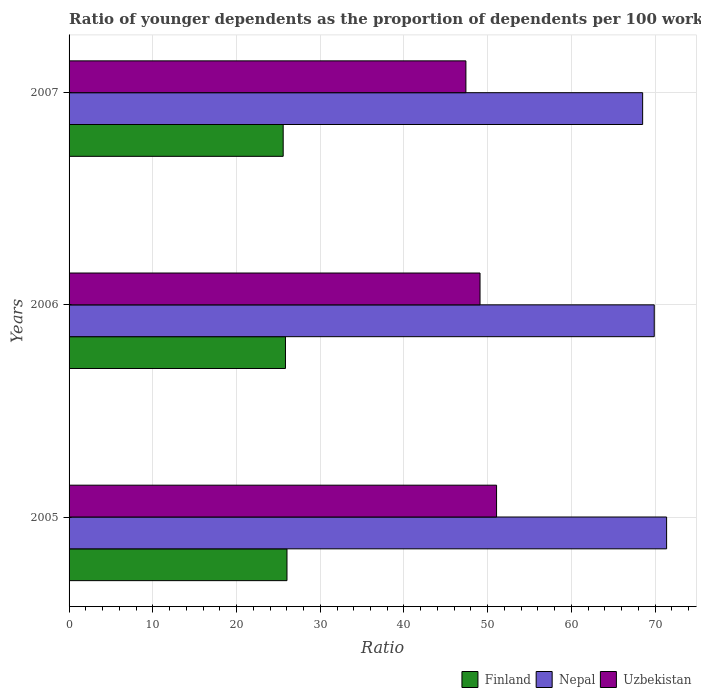Are the number of bars on each tick of the Y-axis equal?
Give a very brief answer. Yes. How many bars are there on the 1st tick from the bottom?
Provide a succinct answer. 3. In how many cases, is the number of bars for a given year not equal to the number of legend labels?
Your response must be concise. 0. What is the age dependency ratio(young) in Finland in 2006?
Ensure brevity in your answer.  25.85. Across all years, what is the maximum age dependency ratio(young) in Uzbekistan?
Your answer should be compact. 51.06. Across all years, what is the minimum age dependency ratio(young) in Uzbekistan?
Your answer should be very brief. 47.4. In which year was the age dependency ratio(young) in Finland maximum?
Offer a terse response. 2005. In which year was the age dependency ratio(young) in Nepal minimum?
Give a very brief answer. 2007. What is the total age dependency ratio(young) in Nepal in the graph?
Your answer should be compact. 209.77. What is the difference between the age dependency ratio(young) in Uzbekistan in 2005 and that in 2006?
Make the answer very short. 1.97. What is the difference between the age dependency ratio(young) in Finland in 2006 and the age dependency ratio(young) in Nepal in 2005?
Keep it short and to the point. -45.52. What is the average age dependency ratio(young) in Finland per year?
Give a very brief answer. 25.82. In the year 2006, what is the difference between the age dependency ratio(young) in Finland and age dependency ratio(young) in Nepal?
Offer a very short reply. -44.05. What is the ratio of the age dependency ratio(young) in Nepal in 2005 to that in 2006?
Offer a terse response. 1.02. Is the difference between the age dependency ratio(young) in Finland in 2005 and 2007 greater than the difference between the age dependency ratio(young) in Nepal in 2005 and 2007?
Provide a succinct answer. No. What is the difference between the highest and the second highest age dependency ratio(young) in Uzbekistan?
Provide a succinct answer. 1.97. What is the difference between the highest and the lowest age dependency ratio(young) in Uzbekistan?
Make the answer very short. 3.66. In how many years, is the age dependency ratio(young) in Nepal greater than the average age dependency ratio(young) in Nepal taken over all years?
Give a very brief answer. 1. What does the 1st bar from the top in 2005 represents?
Ensure brevity in your answer.  Uzbekistan. How many bars are there?
Ensure brevity in your answer.  9. Are all the bars in the graph horizontal?
Your answer should be compact. Yes. Does the graph contain any zero values?
Give a very brief answer. No. Where does the legend appear in the graph?
Your response must be concise. Bottom right. What is the title of the graph?
Provide a short and direct response. Ratio of younger dependents as the proportion of dependents per 100 working-age population. What is the label or title of the X-axis?
Provide a short and direct response. Ratio. What is the label or title of the Y-axis?
Offer a very short reply. Years. What is the Ratio of Finland in 2005?
Provide a succinct answer. 26.03. What is the Ratio of Nepal in 2005?
Ensure brevity in your answer.  71.37. What is the Ratio of Uzbekistan in 2005?
Offer a very short reply. 51.06. What is the Ratio in Finland in 2006?
Provide a succinct answer. 25.85. What is the Ratio in Nepal in 2006?
Keep it short and to the point. 69.89. What is the Ratio of Uzbekistan in 2006?
Your answer should be very brief. 49.09. What is the Ratio of Finland in 2007?
Offer a very short reply. 25.57. What is the Ratio of Nepal in 2007?
Ensure brevity in your answer.  68.51. What is the Ratio in Uzbekistan in 2007?
Your answer should be compact. 47.4. Across all years, what is the maximum Ratio of Finland?
Provide a short and direct response. 26.03. Across all years, what is the maximum Ratio of Nepal?
Give a very brief answer. 71.37. Across all years, what is the maximum Ratio in Uzbekistan?
Your answer should be very brief. 51.06. Across all years, what is the minimum Ratio in Finland?
Your answer should be very brief. 25.57. Across all years, what is the minimum Ratio in Nepal?
Provide a short and direct response. 68.51. Across all years, what is the minimum Ratio in Uzbekistan?
Ensure brevity in your answer.  47.4. What is the total Ratio of Finland in the graph?
Your answer should be compact. 77.45. What is the total Ratio in Nepal in the graph?
Provide a short and direct response. 209.77. What is the total Ratio in Uzbekistan in the graph?
Your answer should be compact. 147.54. What is the difference between the Ratio of Finland in 2005 and that in 2006?
Your answer should be very brief. 0.18. What is the difference between the Ratio in Nepal in 2005 and that in 2006?
Offer a very short reply. 1.48. What is the difference between the Ratio of Uzbekistan in 2005 and that in 2006?
Give a very brief answer. 1.97. What is the difference between the Ratio of Finland in 2005 and that in 2007?
Offer a terse response. 0.45. What is the difference between the Ratio of Nepal in 2005 and that in 2007?
Offer a terse response. 2.86. What is the difference between the Ratio in Uzbekistan in 2005 and that in 2007?
Offer a terse response. 3.66. What is the difference between the Ratio of Finland in 2006 and that in 2007?
Ensure brevity in your answer.  0.27. What is the difference between the Ratio in Nepal in 2006 and that in 2007?
Provide a short and direct response. 1.39. What is the difference between the Ratio of Uzbekistan in 2006 and that in 2007?
Keep it short and to the point. 1.69. What is the difference between the Ratio of Finland in 2005 and the Ratio of Nepal in 2006?
Your response must be concise. -43.87. What is the difference between the Ratio in Finland in 2005 and the Ratio in Uzbekistan in 2006?
Give a very brief answer. -23.06. What is the difference between the Ratio in Nepal in 2005 and the Ratio in Uzbekistan in 2006?
Give a very brief answer. 22.28. What is the difference between the Ratio of Finland in 2005 and the Ratio of Nepal in 2007?
Make the answer very short. -42.48. What is the difference between the Ratio of Finland in 2005 and the Ratio of Uzbekistan in 2007?
Provide a succinct answer. -21.37. What is the difference between the Ratio of Nepal in 2005 and the Ratio of Uzbekistan in 2007?
Offer a very short reply. 23.97. What is the difference between the Ratio in Finland in 2006 and the Ratio in Nepal in 2007?
Ensure brevity in your answer.  -42.66. What is the difference between the Ratio in Finland in 2006 and the Ratio in Uzbekistan in 2007?
Offer a very short reply. -21.55. What is the difference between the Ratio in Nepal in 2006 and the Ratio in Uzbekistan in 2007?
Give a very brief answer. 22.5. What is the average Ratio of Finland per year?
Your answer should be very brief. 25.82. What is the average Ratio of Nepal per year?
Your response must be concise. 69.92. What is the average Ratio in Uzbekistan per year?
Provide a short and direct response. 49.18. In the year 2005, what is the difference between the Ratio in Finland and Ratio in Nepal?
Your answer should be very brief. -45.34. In the year 2005, what is the difference between the Ratio of Finland and Ratio of Uzbekistan?
Provide a succinct answer. -25.03. In the year 2005, what is the difference between the Ratio in Nepal and Ratio in Uzbekistan?
Your answer should be compact. 20.31. In the year 2006, what is the difference between the Ratio of Finland and Ratio of Nepal?
Your answer should be very brief. -44.05. In the year 2006, what is the difference between the Ratio of Finland and Ratio of Uzbekistan?
Your answer should be very brief. -23.24. In the year 2006, what is the difference between the Ratio of Nepal and Ratio of Uzbekistan?
Make the answer very short. 20.81. In the year 2007, what is the difference between the Ratio in Finland and Ratio in Nepal?
Offer a very short reply. -42.93. In the year 2007, what is the difference between the Ratio of Finland and Ratio of Uzbekistan?
Ensure brevity in your answer.  -21.82. In the year 2007, what is the difference between the Ratio of Nepal and Ratio of Uzbekistan?
Make the answer very short. 21.11. What is the ratio of the Ratio of Finland in 2005 to that in 2006?
Ensure brevity in your answer.  1.01. What is the ratio of the Ratio in Nepal in 2005 to that in 2006?
Provide a short and direct response. 1.02. What is the ratio of the Ratio of Uzbekistan in 2005 to that in 2006?
Your answer should be very brief. 1.04. What is the ratio of the Ratio of Finland in 2005 to that in 2007?
Your answer should be very brief. 1.02. What is the ratio of the Ratio of Nepal in 2005 to that in 2007?
Your answer should be very brief. 1.04. What is the ratio of the Ratio of Uzbekistan in 2005 to that in 2007?
Your answer should be compact. 1.08. What is the ratio of the Ratio of Finland in 2006 to that in 2007?
Offer a terse response. 1.01. What is the ratio of the Ratio in Nepal in 2006 to that in 2007?
Your response must be concise. 1.02. What is the ratio of the Ratio of Uzbekistan in 2006 to that in 2007?
Offer a terse response. 1.04. What is the difference between the highest and the second highest Ratio in Finland?
Provide a short and direct response. 0.18. What is the difference between the highest and the second highest Ratio in Nepal?
Offer a terse response. 1.48. What is the difference between the highest and the second highest Ratio of Uzbekistan?
Offer a terse response. 1.97. What is the difference between the highest and the lowest Ratio of Finland?
Offer a terse response. 0.45. What is the difference between the highest and the lowest Ratio of Nepal?
Your answer should be compact. 2.86. What is the difference between the highest and the lowest Ratio in Uzbekistan?
Provide a succinct answer. 3.66. 